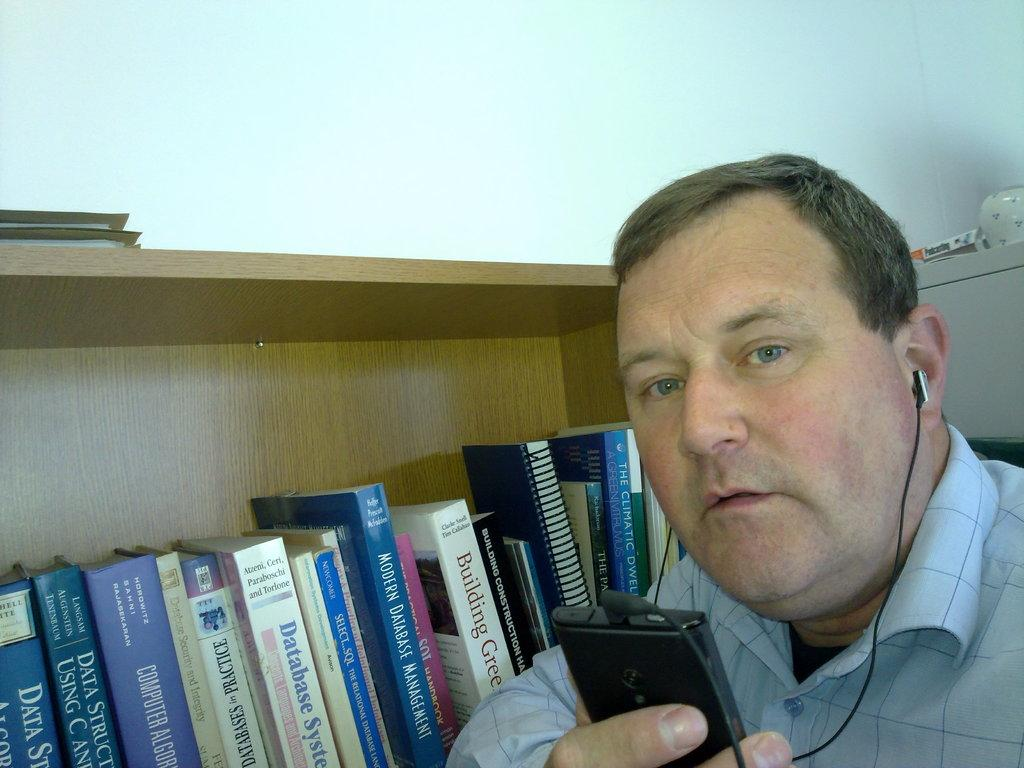<image>
Render a clear and concise summary of the photo. A man is listening to music with earphones next to a building construction book. 